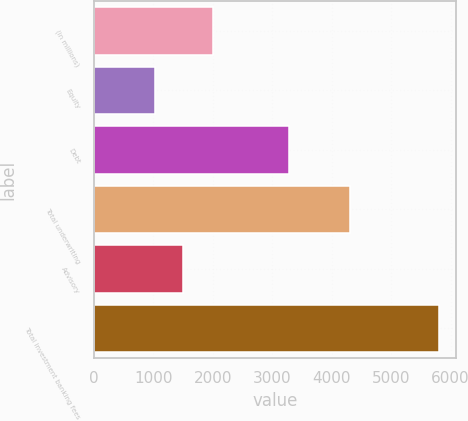Convert chart. <chart><loc_0><loc_0><loc_500><loc_500><bar_chart><fcel>(in millions)<fcel>Equity<fcel>Debt<fcel>Total underwriting<fcel>Advisory<fcel>Total investment banking fees<nl><fcel>2012<fcel>1026<fcel>3290<fcel>4316<fcel>1504.2<fcel>5808<nl></chart> 